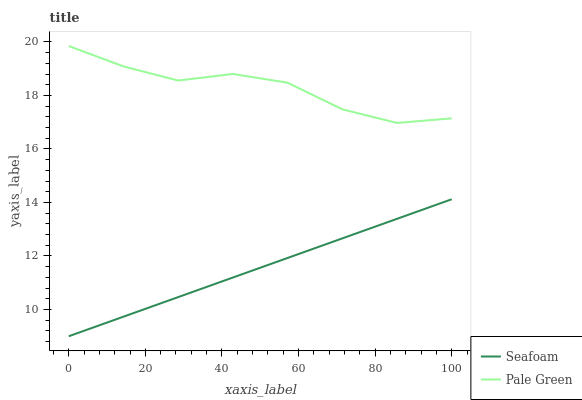Does Seafoam have the maximum area under the curve?
Answer yes or no. No. Is Seafoam the roughest?
Answer yes or no. No. Does Seafoam have the highest value?
Answer yes or no. No. Is Seafoam less than Pale Green?
Answer yes or no. Yes. Is Pale Green greater than Seafoam?
Answer yes or no. Yes. Does Seafoam intersect Pale Green?
Answer yes or no. No. 